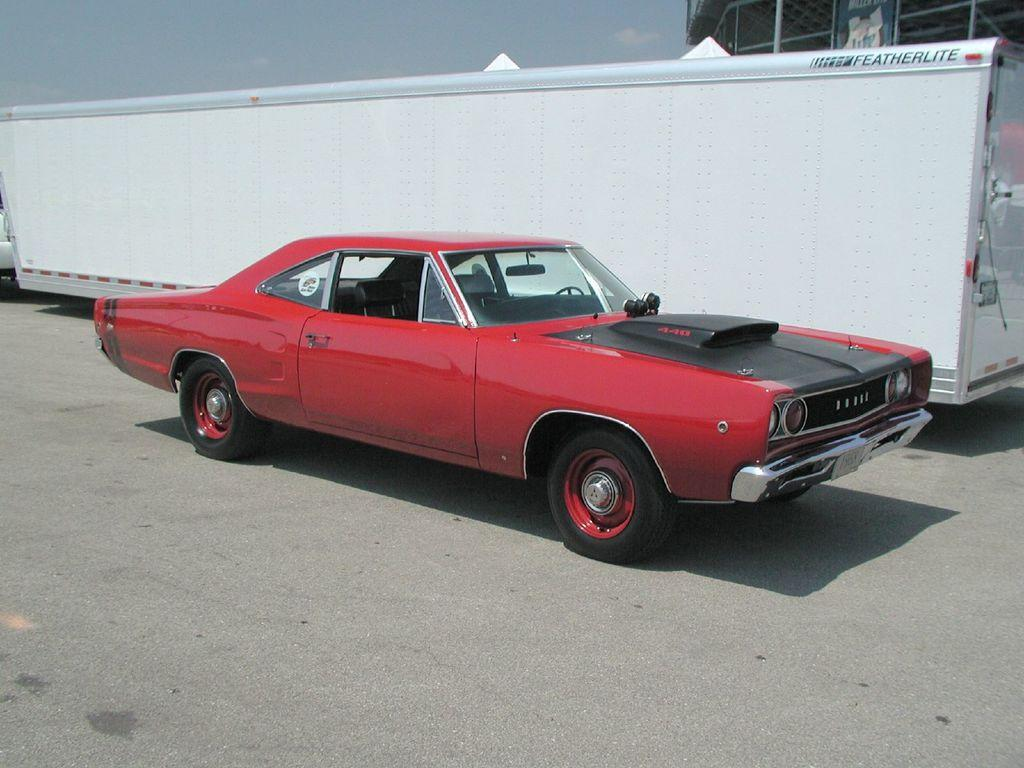What type of vehicle can be seen on the road in the image? There is a red car on the road in the image. What else is visible in the image besides the car? There is a building and the sky visible in the image. What is the color of the sky in the image? The sky is visible in the background of the image, and it has clouds present. What type of nut is being used to cook the rice in the image? There is no nut or rice present in the image; it features a red car on the road, a building, and the sky. 